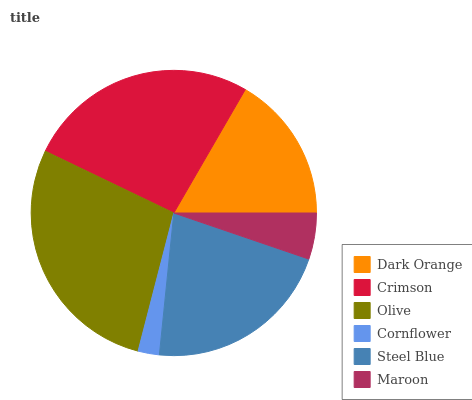Is Cornflower the minimum?
Answer yes or no. Yes. Is Olive the maximum?
Answer yes or no. Yes. Is Crimson the minimum?
Answer yes or no. No. Is Crimson the maximum?
Answer yes or no. No. Is Crimson greater than Dark Orange?
Answer yes or no. Yes. Is Dark Orange less than Crimson?
Answer yes or no. Yes. Is Dark Orange greater than Crimson?
Answer yes or no. No. Is Crimson less than Dark Orange?
Answer yes or no. No. Is Steel Blue the high median?
Answer yes or no. Yes. Is Dark Orange the low median?
Answer yes or no. Yes. Is Maroon the high median?
Answer yes or no. No. Is Crimson the low median?
Answer yes or no. No. 